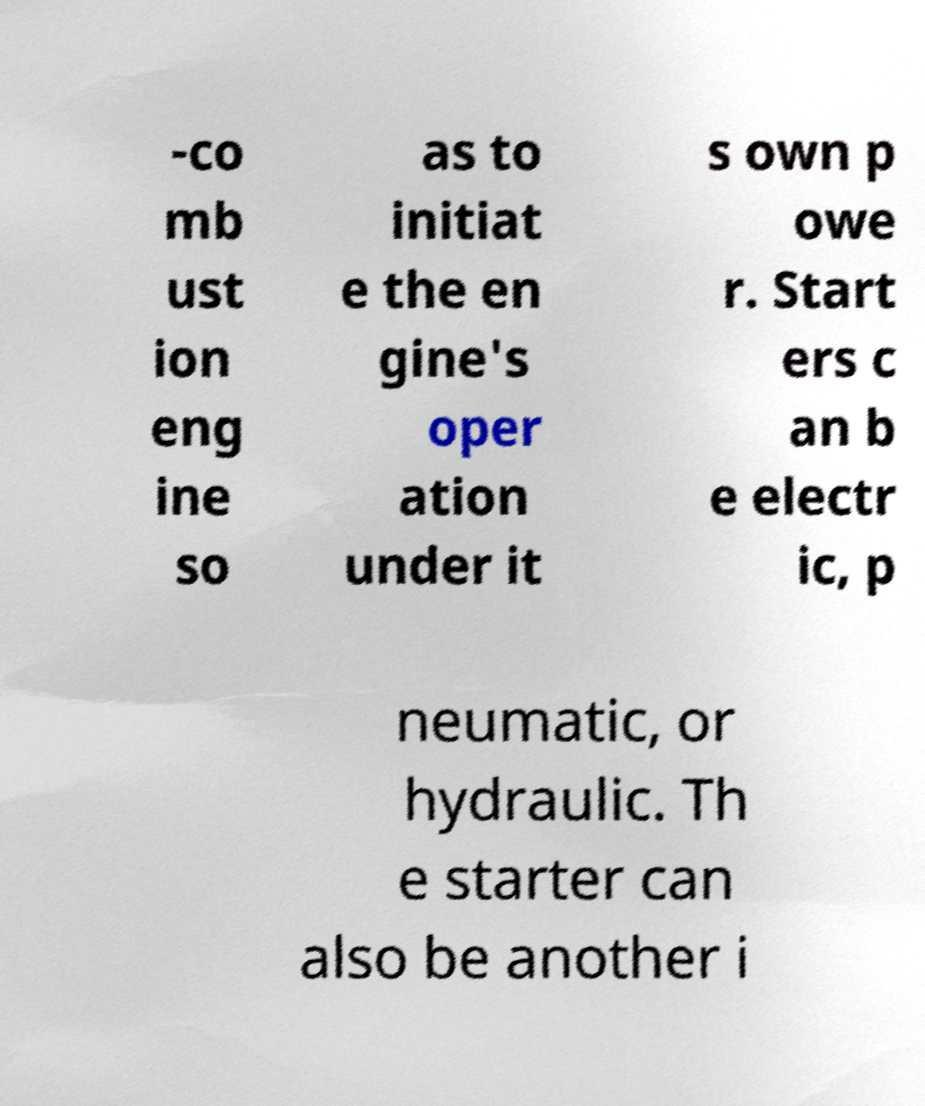Could you extract and type out the text from this image? -co mb ust ion eng ine so as to initiat e the en gine's oper ation under it s own p owe r. Start ers c an b e electr ic, p neumatic, or hydraulic. Th e starter can also be another i 